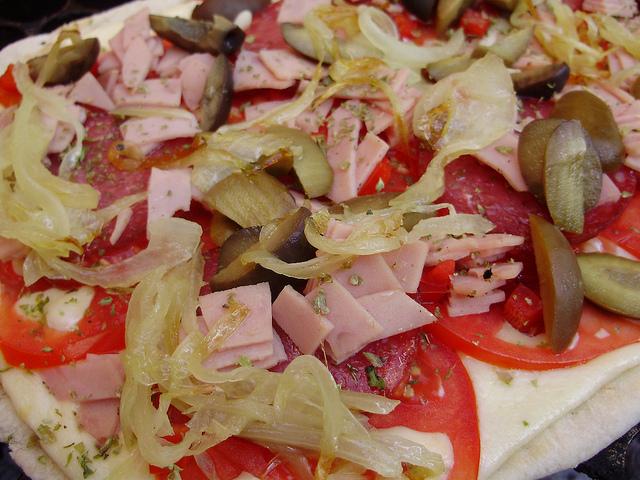Are there tomatoes in the picture?
Concise answer only. Yes. Are there apples in this dish?
Concise answer only. No. How many foods are green?
Concise answer only. 2. Is there melted cheese on this dish?
Write a very short answer. No. What meat is in the picture?
Keep it brief. Ham. 